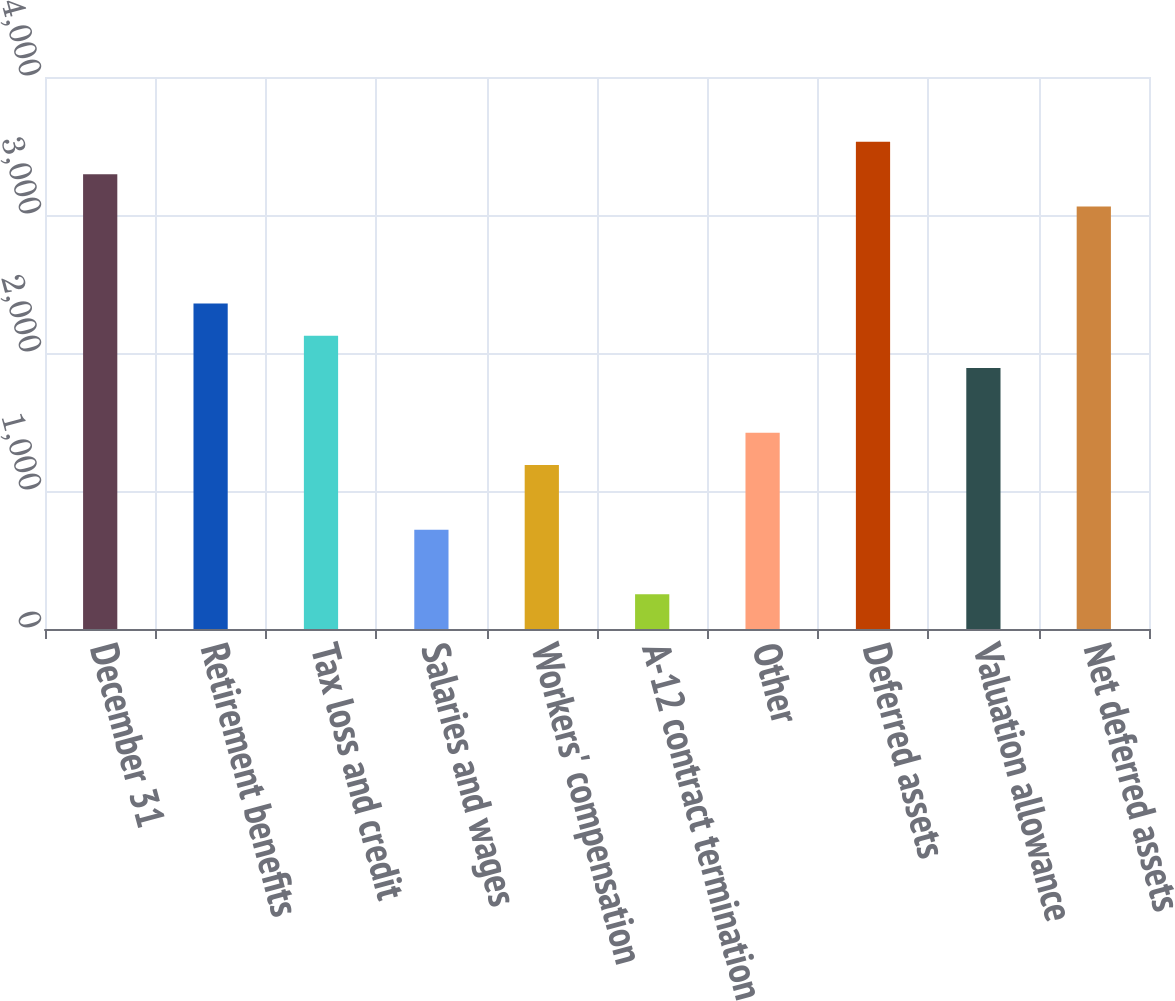Convert chart to OTSL. <chart><loc_0><loc_0><loc_500><loc_500><bar_chart><fcel>December 31<fcel>Retirement benefits<fcel>Tax loss and credit<fcel>Salaries and wages<fcel>Workers' compensation<fcel>A-12 contract termination<fcel>Other<fcel>Deferred assets<fcel>Valuation allowance<fcel>Net deferred assets<nl><fcel>3295.8<fcel>2359<fcel>2124.8<fcel>719.6<fcel>1188<fcel>251.2<fcel>1422.2<fcel>3530<fcel>1890.6<fcel>3061.6<nl></chart> 